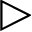<formula> <loc_0><loc_0><loc_500><loc_500>\triangleright</formula> 